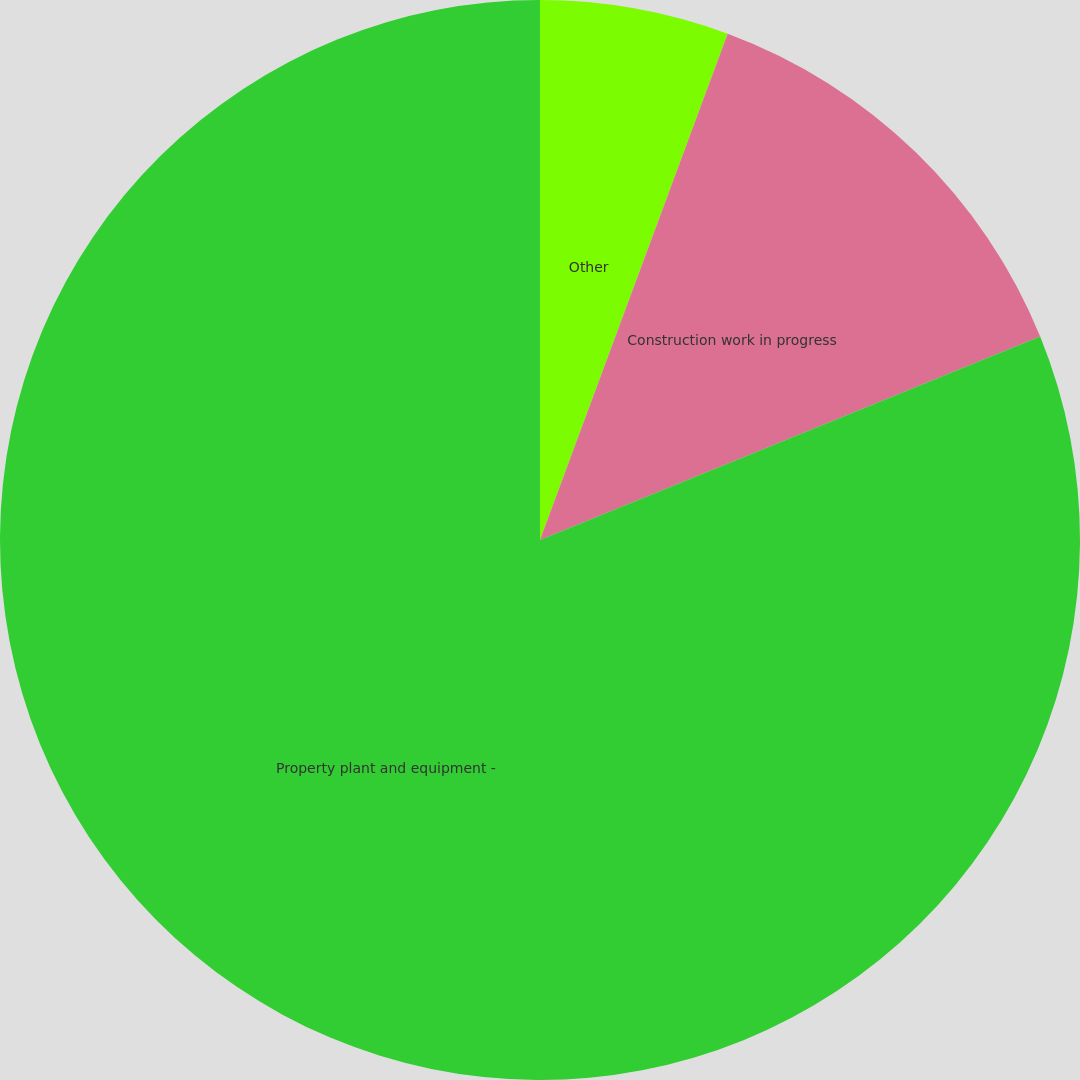Convert chart to OTSL. <chart><loc_0><loc_0><loc_500><loc_500><pie_chart><fcel>Other<fcel>Construction work in progress<fcel>Property plant and equipment -<nl><fcel>5.65%<fcel>13.2%<fcel>81.15%<nl></chart> 